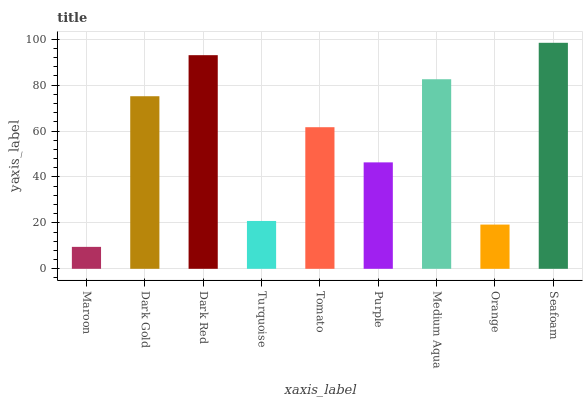Is Maroon the minimum?
Answer yes or no. Yes. Is Seafoam the maximum?
Answer yes or no. Yes. Is Dark Gold the minimum?
Answer yes or no. No. Is Dark Gold the maximum?
Answer yes or no. No. Is Dark Gold greater than Maroon?
Answer yes or no. Yes. Is Maroon less than Dark Gold?
Answer yes or no. Yes. Is Maroon greater than Dark Gold?
Answer yes or no. No. Is Dark Gold less than Maroon?
Answer yes or no. No. Is Tomato the high median?
Answer yes or no. Yes. Is Tomato the low median?
Answer yes or no. Yes. Is Dark Gold the high median?
Answer yes or no. No. Is Turquoise the low median?
Answer yes or no. No. 